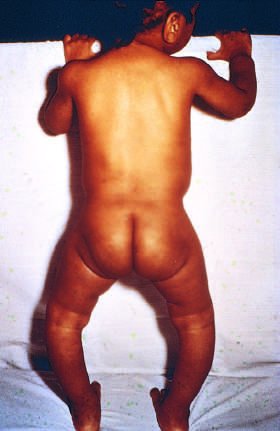did bile duct cells and canals of hering mineralize bone in a child with rickets?
Answer the question using a single word or phrase. No 